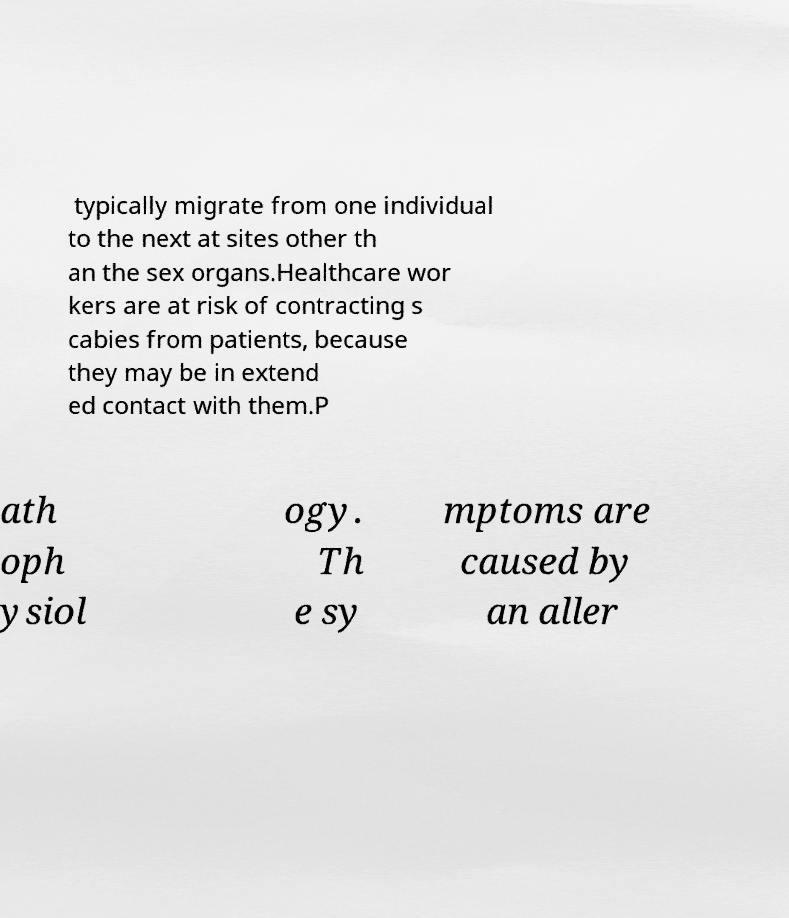What messages or text are displayed in this image? I need them in a readable, typed format. typically migrate from one individual to the next at sites other th an the sex organs.Healthcare wor kers are at risk of contracting s cabies from patients, because they may be in extend ed contact with them.P ath oph ysiol ogy. Th e sy mptoms are caused by an aller 